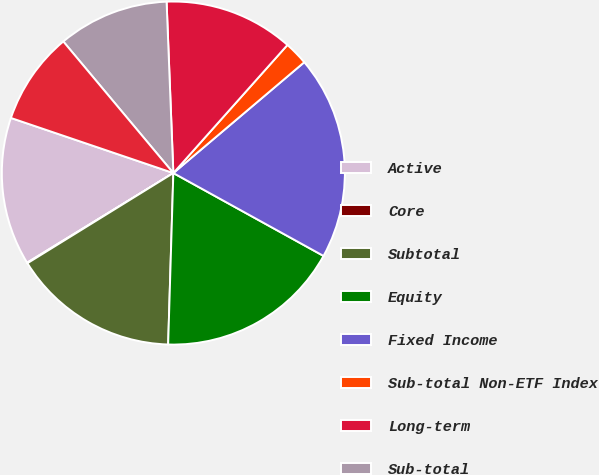<chart> <loc_0><loc_0><loc_500><loc_500><pie_chart><fcel>Active<fcel>Core<fcel>Subtotal<fcel>Equity<fcel>Fixed Income<fcel>Sub-total Non-ETF Index<fcel>Long-term<fcel>Sub-total<fcel>Total<nl><fcel>13.96%<fcel>0.06%<fcel>15.71%<fcel>17.46%<fcel>19.21%<fcel>2.24%<fcel>12.21%<fcel>10.46%<fcel>8.71%<nl></chart> 